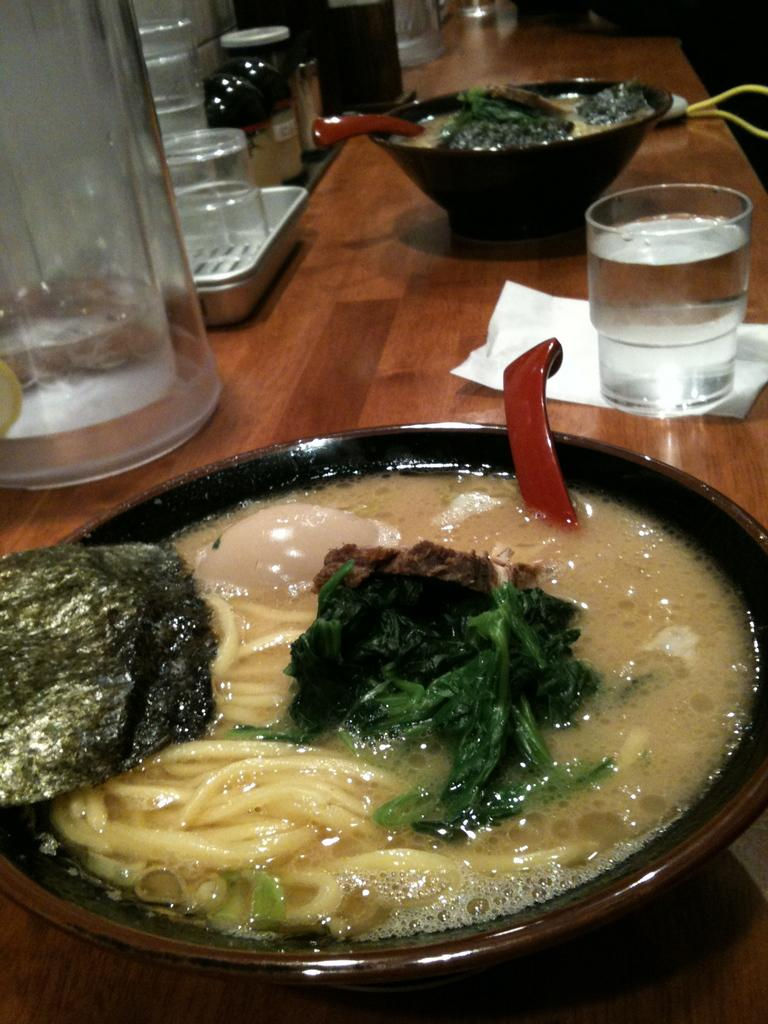What is in the bowls that are visible in the image? There is food in the bowls in the image. What can be seen on the left side of the image? There are many bottles at the left side of the image. What is the glass containing in the image? There is a glass with liquid in the image. What is the main piece of furniture in the image? There is a table in the image. Can you see a mark on the hill in the image? There is no hill present in the image, so it is not possible to see a mark on it. 